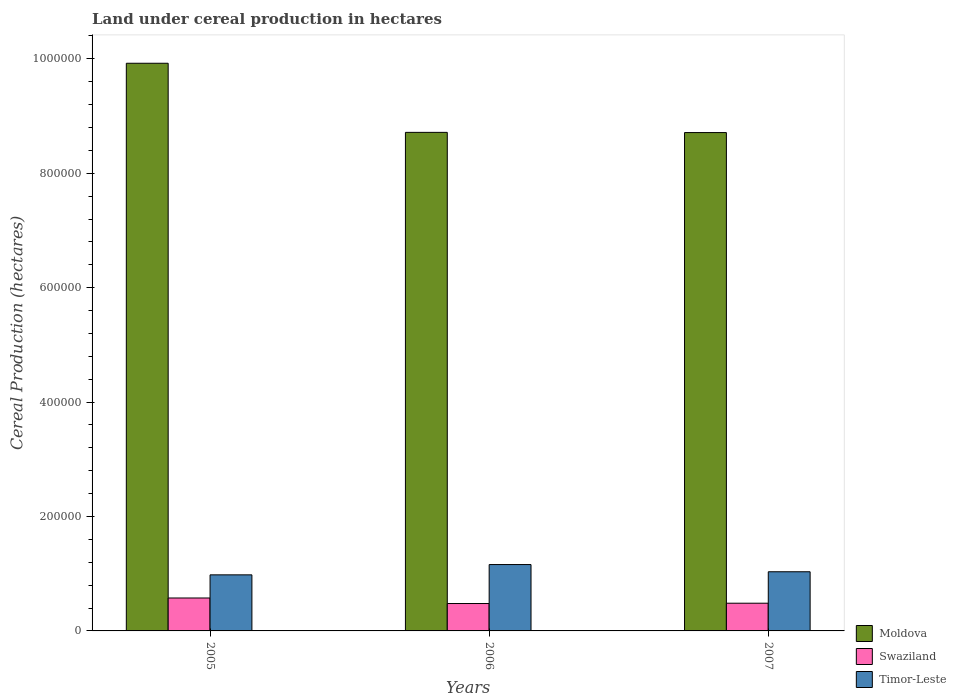How many different coloured bars are there?
Give a very brief answer. 3. Are the number of bars on each tick of the X-axis equal?
Offer a terse response. Yes. How many bars are there on the 2nd tick from the left?
Provide a succinct answer. 3. How many bars are there on the 3rd tick from the right?
Make the answer very short. 3. What is the land under cereal production in Swaziland in 2005?
Your answer should be compact. 5.75e+04. Across all years, what is the maximum land under cereal production in Timor-Leste?
Ensure brevity in your answer.  1.16e+05. Across all years, what is the minimum land under cereal production in Swaziland?
Make the answer very short. 4.79e+04. What is the total land under cereal production in Timor-Leste in the graph?
Offer a terse response. 3.17e+05. What is the difference between the land under cereal production in Moldova in 2006 and that in 2007?
Your response must be concise. 379. What is the difference between the land under cereal production in Timor-Leste in 2005 and the land under cereal production in Moldova in 2006?
Keep it short and to the point. -7.73e+05. What is the average land under cereal production in Swaziland per year?
Keep it short and to the point. 5.13e+04. In the year 2007, what is the difference between the land under cereal production in Timor-Leste and land under cereal production in Swaziland?
Make the answer very short. 5.50e+04. What is the ratio of the land under cereal production in Swaziland in 2005 to that in 2006?
Ensure brevity in your answer.  1.2. What is the difference between the highest and the second highest land under cereal production in Timor-Leste?
Make the answer very short. 1.26e+04. What is the difference between the highest and the lowest land under cereal production in Swaziland?
Keep it short and to the point. 9643. In how many years, is the land under cereal production in Timor-Leste greater than the average land under cereal production in Timor-Leste taken over all years?
Keep it short and to the point. 1. What does the 1st bar from the left in 2005 represents?
Offer a very short reply. Moldova. What does the 3rd bar from the right in 2007 represents?
Make the answer very short. Moldova. Is it the case that in every year, the sum of the land under cereal production in Swaziland and land under cereal production in Timor-Leste is greater than the land under cereal production in Moldova?
Offer a very short reply. No. How many bars are there?
Offer a very short reply. 9. What is the difference between two consecutive major ticks on the Y-axis?
Ensure brevity in your answer.  2.00e+05. Does the graph contain grids?
Offer a terse response. No. Where does the legend appear in the graph?
Keep it short and to the point. Bottom right. How are the legend labels stacked?
Give a very brief answer. Vertical. What is the title of the graph?
Offer a terse response. Land under cereal production in hectares. What is the label or title of the Y-axis?
Provide a succinct answer. Cereal Production (hectares). What is the Cereal Production (hectares) of Moldova in 2005?
Your answer should be compact. 9.92e+05. What is the Cereal Production (hectares) of Swaziland in 2005?
Your answer should be very brief. 5.75e+04. What is the Cereal Production (hectares) of Timor-Leste in 2005?
Keep it short and to the point. 9.80e+04. What is the Cereal Production (hectares) in Moldova in 2006?
Your answer should be very brief. 8.71e+05. What is the Cereal Production (hectares) in Swaziland in 2006?
Provide a succinct answer. 4.79e+04. What is the Cereal Production (hectares) in Timor-Leste in 2006?
Your answer should be compact. 1.16e+05. What is the Cereal Production (hectares) of Moldova in 2007?
Offer a terse response. 8.71e+05. What is the Cereal Production (hectares) of Swaziland in 2007?
Your answer should be compact. 4.84e+04. What is the Cereal Production (hectares) of Timor-Leste in 2007?
Give a very brief answer. 1.03e+05. Across all years, what is the maximum Cereal Production (hectares) in Moldova?
Keep it short and to the point. 9.92e+05. Across all years, what is the maximum Cereal Production (hectares) of Swaziland?
Your answer should be compact. 5.75e+04. Across all years, what is the maximum Cereal Production (hectares) of Timor-Leste?
Keep it short and to the point. 1.16e+05. Across all years, what is the minimum Cereal Production (hectares) of Moldova?
Your response must be concise. 8.71e+05. Across all years, what is the minimum Cereal Production (hectares) of Swaziland?
Your response must be concise. 4.79e+04. Across all years, what is the minimum Cereal Production (hectares) in Timor-Leste?
Give a very brief answer. 9.80e+04. What is the total Cereal Production (hectares) in Moldova in the graph?
Offer a very short reply. 2.73e+06. What is the total Cereal Production (hectares) of Swaziland in the graph?
Ensure brevity in your answer.  1.54e+05. What is the total Cereal Production (hectares) of Timor-Leste in the graph?
Provide a succinct answer. 3.17e+05. What is the difference between the Cereal Production (hectares) in Moldova in 2005 and that in 2006?
Provide a succinct answer. 1.21e+05. What is the difference between the Cereal Production (hectares) in Swaziland in 2005 and that in 2006?
Make the answer very short. 9643. What is the difference between the Cereal Production (hectares) of Timor-Leste in 2005 and that in 2006?
Offer a very short reply. -1.80e+04. What is the difference between the Cereal Production (hectares) of Moldova in 2005 and that in 2007?
Provide a succinct answer. 1.21e+05. What is the difference between the Cereal Production (hectares) in Swaziland in 2005 and that in 2007?
Give a very brief answer. 9115. What is the difference between the Cereal Production (hectares) in Timor-Leste in 2005 and that in 2007?
Offer a very short reply. -5400. What is the difference between the Cereal Production (hectares) in Moldova in 2006 and that in 2007?
Provide a succinct answer. 379. What is the difference between the Cereal Production (hectares) of Swaziland in 2006 and that in 2007?
Your answer should be compact. -528. What is the difference between the Cereal Production (hectares) of Timor-Leste in 2006 and that in 2007?
Provide a succinct answer. 1.26e+04. What is the difference between the Cereal Production (hectares) in Moldova in 2005 and the Cereal Production (hectares) in Swaziland in 2006?
Your response must be concise. 9.44e+05. What is the difference between the Cereal Production (hectares) in Moldova in 2005 and the Cereal Production (hectares) in Timor-Leste in 2006?
Offer a very short reply. 8.76e+05. What is the difference between the Cereal Production (hectares) of Swaziland in 2005 and the Cereal Production (hectares) of Timor-Leste in 2006?
Keep it short and to the point. -5.85e+04. What is the difference between the Cereal Production (hectares) of Moldova in 2005 and the Cereal Production (hectares) of Swaziland in 2007?
Your answer should be very brief. 9.44e+05. What is the difference between the Cereal Production (hectares) of Moldova in 2005 and the Cereal Production (hectares) of Timor-Leste in 2007?
Keep it short and to the point. 8.89e+05. What is the difference between the Cereal Production (hectares) in Swaziland in 2005 and the Cereal Production (hectares) in Timor-Leste in 2007?
Your response must be concise. -4.59e+04. What is the difference between the Cereal Production (hectares) in Moldova in 2006 and the Cereal Production (hectares) in Swaziland in 2007?
Offer a very short reply. 8.23e+05. What is the difference between the Cereal Production (hectares) of Moldova in 2006 and the Cereal Production (hectares) of Timor-Leste in 2007?
Provide a short and direct response. 7.68e+05. What is the difference between the Cereal Production (hectares) of Swaziland in 2006 and the Cereal Production (hectares) of Timor-Leste in 2007?
Provide a succinct answer. -5.55e+04. What is the average Cereal Production (hectares) of Moldova per year?
Keep it short and to the point. 9.12e+05. What is the average Cereal Production (hectares) in Swaziland per year?
Provide a succinct answer. 5.13e+04. What is the average Cereal Production (hectares) in Timor-Leste per year?
Make the answer very short. 1.06e+05. In the year 2005, what is the difference between the Cereal Production (hectares) of Moldova and Cereal Production (hectares) of Swaziland?
Provide a succinct answer. 9.35e+05. In the year 2005, what is the difference between the Cereal Production (hectares) in Moldova and Cereal Production (hectares) in Timor-Leste?
Ensure brevity in your answer.  8.94e+05. In the year 2005, what is the difference between the Cereal Production (hectares) of Swaziland and Cereal Production (hectares) of Timor-Leste?
Keep it short and to the point. -4.05e+04. In the year 2006, what is the difference between the Cereal Production (hectares) of Moldova and Cereal Production (hectares) of Swaziland?
Your response must be concise. 8.24e+05. In the year 2006, what is the difference between the Cereal Production (hectares) in Moldova and Cereal Production (hectares) in Timor-Leste?
Keep it short and to the point. 7.55e+05. In the year 2006, what is the difference between the Cereal Production (hectares) of Swaziland and Cereal Production (hectares) of Timor-Leste?
Give a very brief answer. -6.81e+04. In the year 2007, what is the difference between the Cereal Production (hectares) in Moldova and Cereal Production (hectares) in Swaziland?
Ensure brevity in your answer.  8.23e+05. In the year 2007, what is the difference between the Cereal Production (hectares) in Moldova and Cereal Production (hectares) in Timor-Leste?
Offer a very short reply. 7.68e+05. In the year 2007, what is the difference between the Cereal Production (hectares) of Swaziland and Cereal Production (hectares) of Timor-Leste?
Ensure brevity in your answer.  -5.50e+04. What is the ratio of the Cereal Production (hectares) of Moldova in 2005 to that in 2006?
Offer a very short reply. 1.14. What is the ratio of the Cereal Production (hectares) of Swaziland in 2005 to that in 2006?
Provide a short and direct response. 1.2. What is the ratio of the Cereal Production (hectares) in Timor-Leste in 2005 to that in 2006?
Your answer should be very brief. 0.84. What is the ratio of the Cereal Production (hectares) of Moldova in 2005 to that in 2007?
Make the answer very short. 1.14. What is the ratio of the Cereal Production (hectares) of Swaziland in 2005 to that in 2007?
Offer a very short reply. 1.19. What is the ratio of the Cereal Production (hectares) of Timor-Leste in 2005 to that in 2007?
Make the answer very short. 0.95. What is the ratio of the Cereal Production (hectares) of Timor-Leste in 2006 to that in 2007?
Provide a short and direct response. 1.12. What is the difference between the highest and the second highest Cereal Production (hectares) of Moldova?
Provide a succinct answer. 1.21e+05. What is the difference between the highest and the second highest Cereal Production (hectares) in Swaziland?
Provide a succinct answer. 9115. What is the difference between the highest and the second highest Cereal Production (hectares) of Timor-Leste?
Your response must be concise. 1.26e+04. What is the difference between the highest and the lowest Cereal Production (hectares) of Moldova?
Provide a succinct answer. 1.21e+05. What is the difference between the highest and the lowest Cereal Production (hectares) of Swaziland?
Ensure brevity in your answer.  9643. What is the difference between the highest and the lowest Cereal Production (hectares) of Timor-Leste?
Offer a very short reply. 1.80e+04. 